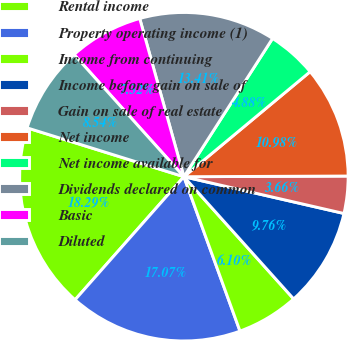Convert chart. <chart><loc_0><loc_0><loc_500><loc_500><pie_chart><fcel>Rental income<fcel>Property operating income (1)<fcel>Income from continuing<fcel>Income before gain on sale of<fcel>Gain on sale of real estate<fcel>Net income<fcel>Net income available for<fcel>Dividends declared on common<fcel>Basic<fcel>Diluted<nl><fcel>18.29%<fcel>17.07%<fcel>6.1%<fcel>9.76%<fcel>3.66%<fcel>10.98%<fcel>4.88%<fcel>13.41%<fcel>7.32%<fcel>8.54%<nl></chart> 